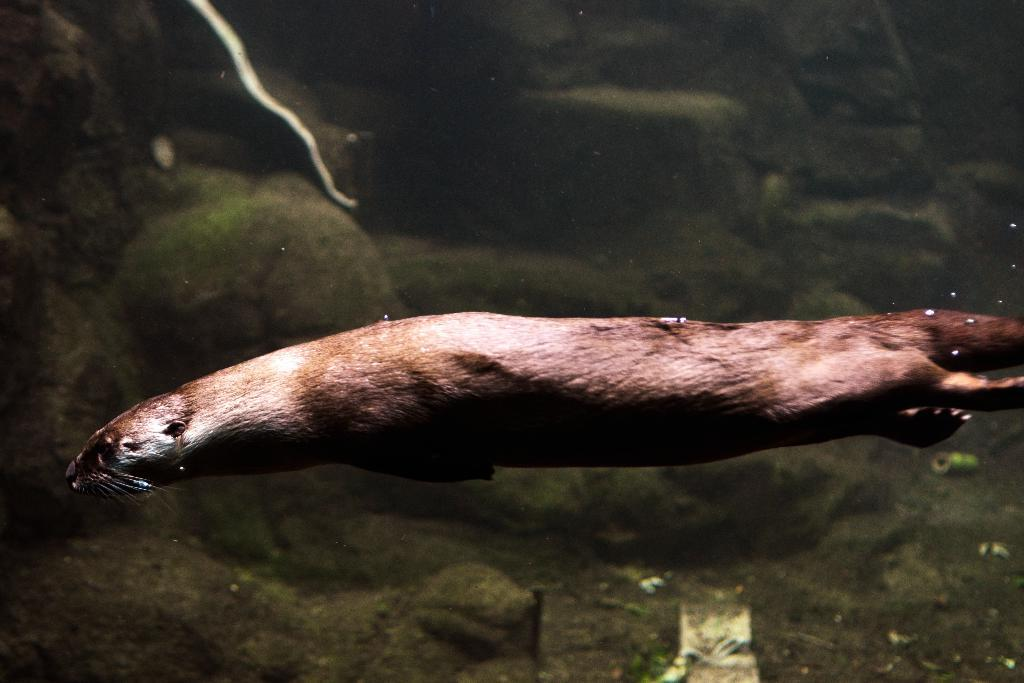What is in the water in the image? There is an animal in the water in the image. What can be seen in the background of the image? There are rocks in the background of the image. What type of plants can be seen growing on the animal in the image? There are no plants visible on the animal in the image. 